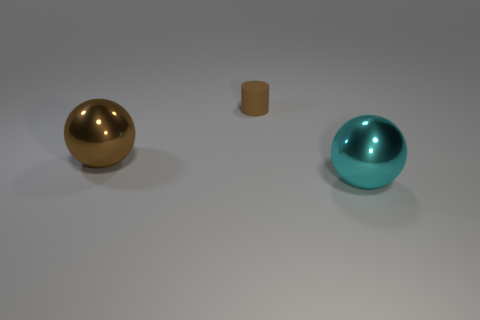Add 2 matte things. How many objects exist? 5 Subtract all spheres. How many objects are left? 1 Add 2 small green rubber cylinders. How many small green rubber cylinders exist? 2 Subtract 0 cyan cubes. How many objects are left? 3 Subtract all large cyan things. Subtract all green balls. How many objects are left? 2 Add 1 small cylinders. How many small cylinders are left? 2 